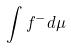Convert formula to latex. <formula><loc_0><loc_0><loc_500><loc_500>\int f ^ { - } d \mu</formula> 